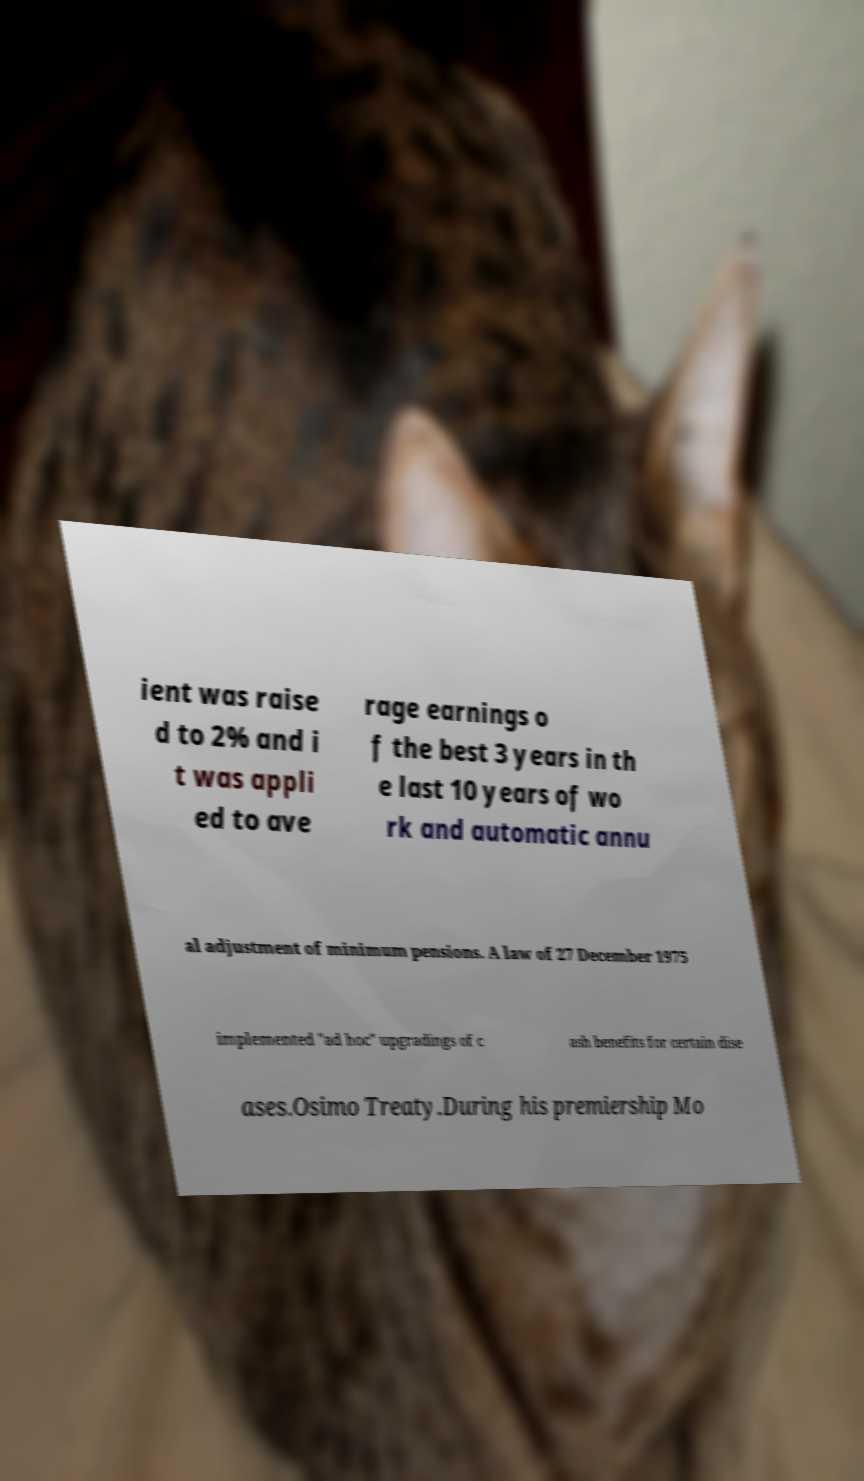Please identify and transcribe the text found in this image. ient was raise d to 2% and i t was appli ed to ave rage earnings o f the best 3 years in th e last 10 years of wo rk and automatic annu al adjustment of minimum pensions. A law of 27 December 1975 implemented "ad hoc" upgradings of c ash benefits for certain dise ases.Osimo Treaty.During his premiership Mo 